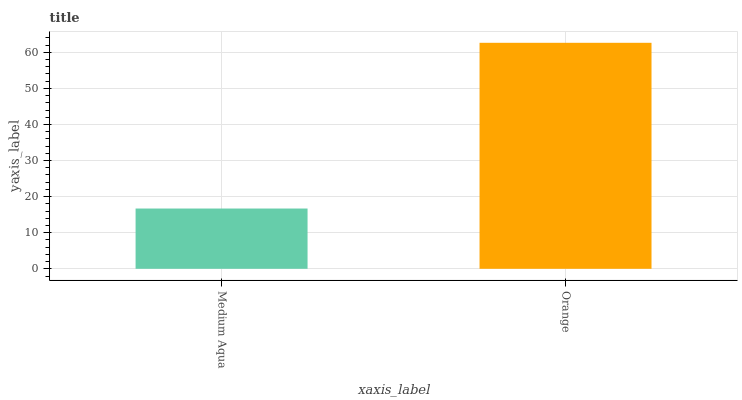Is Orange the minimum?
Answer yes or no. No. Is Orange greater than Medium Aqua?
Answer yes or no. Yes. Is Medium Aqua less than Orange?
Answer yes or no. Yes. Is Medium Aqua greater than Orange?
Answer yes or no. No. Is Orange less than Medium Aqua?
Answer yes or no. No. Is Orange the high median?
Answer yes or no. Yes. Is Medium Aqua the low median?
Answer yes or no. Yes. Is Medium Aqua the high median?
Answer yes or no. No. Is Orange the low median?
Answer yes or no. No. 